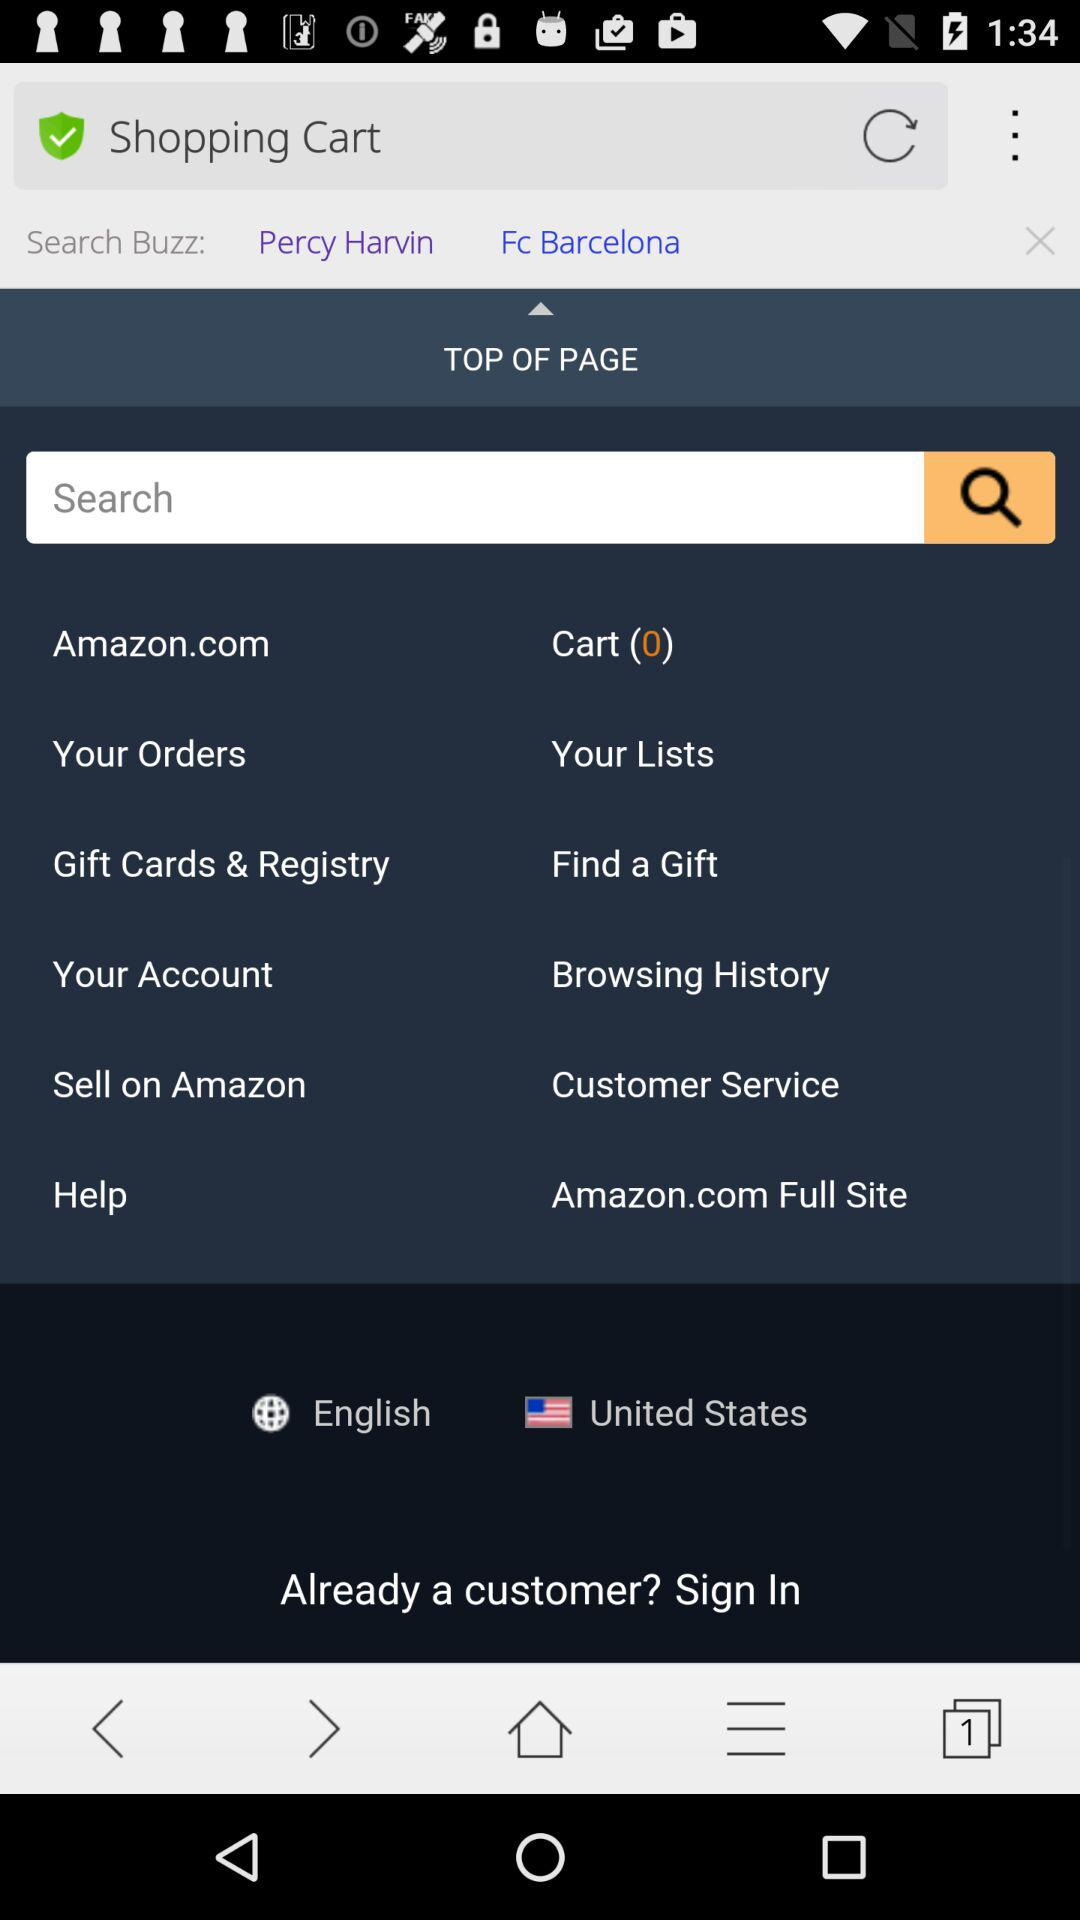How many items are there in the cart? There are 0 items. 